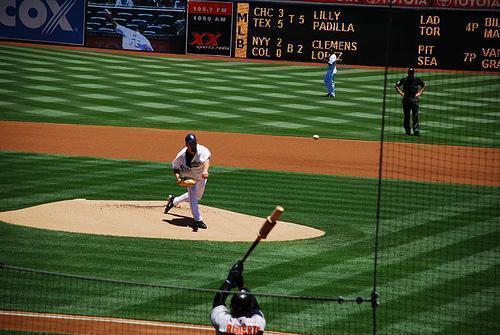Who conducts baseball league?
Select the accurate response from the four choices given to answer the question.
Options: Mlb, iit, tts, nht. Mlb. 